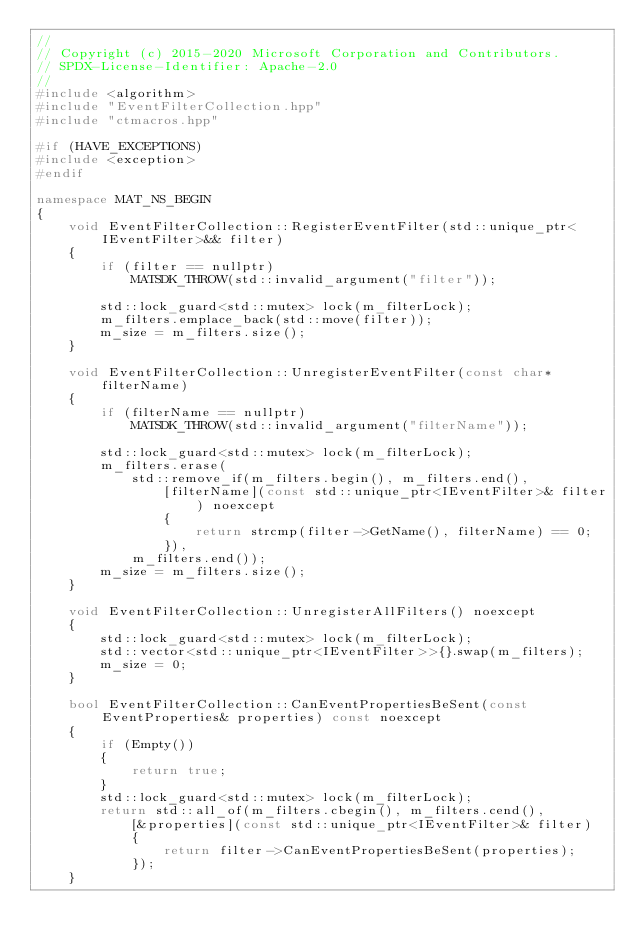Convert code to text. <code><loc_0><loc_0><loc_500><loc_500><_C++_>//
// Copyright (c) 2015-2020 Microsoft Corporation and Contributors.
// SPDX-License-Identifier: Apache-2.0
//
#include <algorithm>
#include "EventFilterCollection.hpp"
#include "ctmacros.hpp"

#if (HAVE_EXCEPTIONS)
#include <exception>
#endif

namespace MAT_NS_BEGIN
{
    void EventFilterCollection::RegisterEventFilter(std::unique_ptr<IEventFilter>&& filter)
    {
        if (filter == nullptr)
            MATSDK_THROW(std::invalid_argument("filter"));

        std::lock_guard<std::mutex> lock(m_filterLock);
        m_filters.emplace_back(std::move(filter));
        m_size = m_filters.size();
    }

    void EventFilterCollection::UnregisterEventFilter(const char* filterName)
    {
        if (filterName == nullptr)
            MATSDK_THROW(std::invalid_argument("filterName"));

        std::lock_guard<std::mutex> lock(m_filterLock);
        m_filters.erase(
            std::remove_if(m_filters.begin(), m_filters.end(), 
                [filterName](const std::unique_ptr<IEventFilter>& filter) noexcept
                {
                    return strcmp(filter->GetName(), filterName) == 0;
                }),
            m_filters.end());
        m_size = m_filters.size();
    }

    void EventFilterCollection::UnregisterAllFilters() noexcept
    {
        std::lock_guard<std::mutex> lock(m_filterLock);
        std::vector<std::unique_ptr<IEventFilter>>{}.swap(m_filters);
        m_size = 0;
    }

    bool EventFilterCollection::CanEventPropertiesBeSent(const EventProperties& properties) const noexcept
    {
        if (Empty())
        {
            return true;
        }
        std::lock_guard<std::mutex> lock(m_filterLock);
        return std::all_of(m_filters.cbegin(), m_filters.cend(), 
            [&properties](const std::unique_ptr<IEventFilter>& filter)
            {
                return filter->CanEventPropertiesBeSent(properties);
            });
    }
</code> 